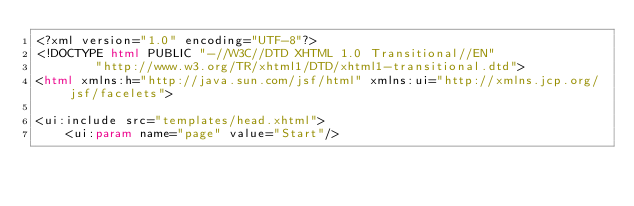<code> <loc_0><loc_0><loc_500><loc_500><_HTML_><?xml version="1.0" encoding="UTF-8"?>
<!DOCTYPE html PUBLIC "-//W3C//DTD XHTML 1.0 Transitional//EN"
        "http://www.w3.org/TR/xhtml1/DTD/xhtml1-transitional.dtd">
<html xmlns:h="http://java.sun.com/jsf/html" xmlns:ui="http://xmlns.jcp.org/jsf/facelets">

<ui:include src="templates/head.xhtml">
    <ui:param name="page" value="Start"/></code> 